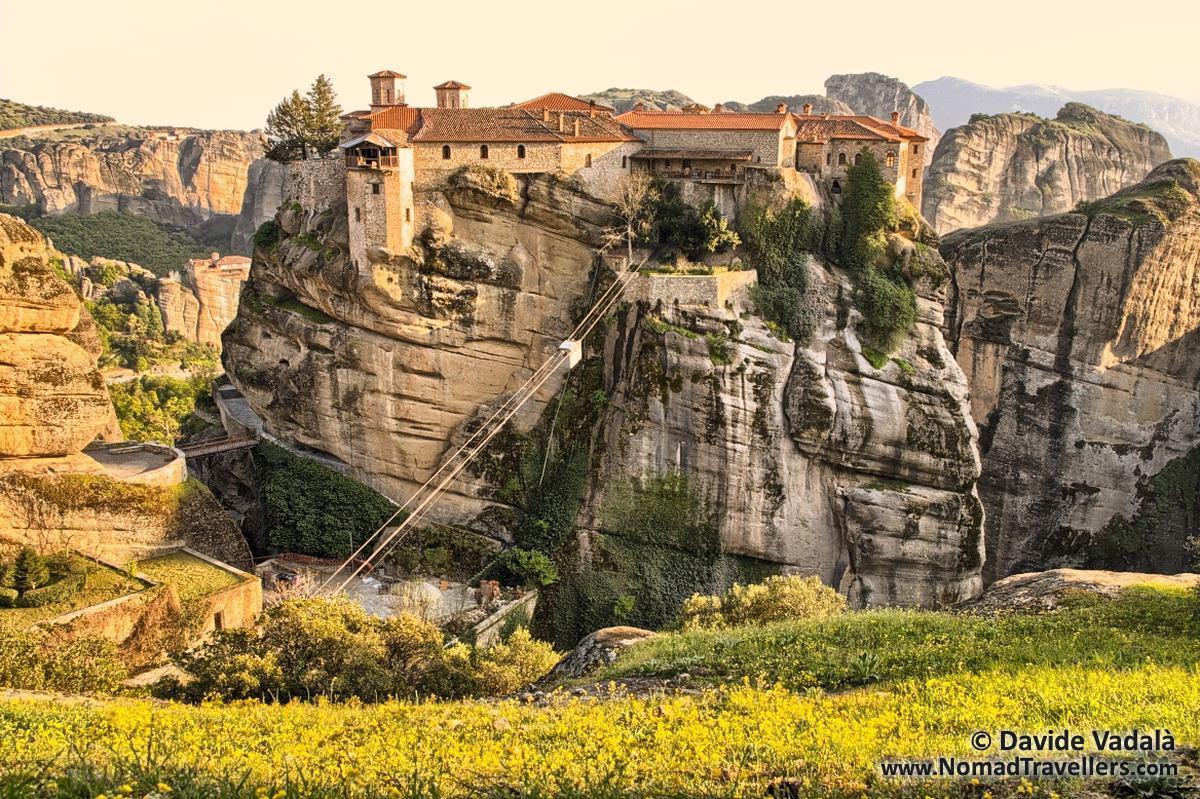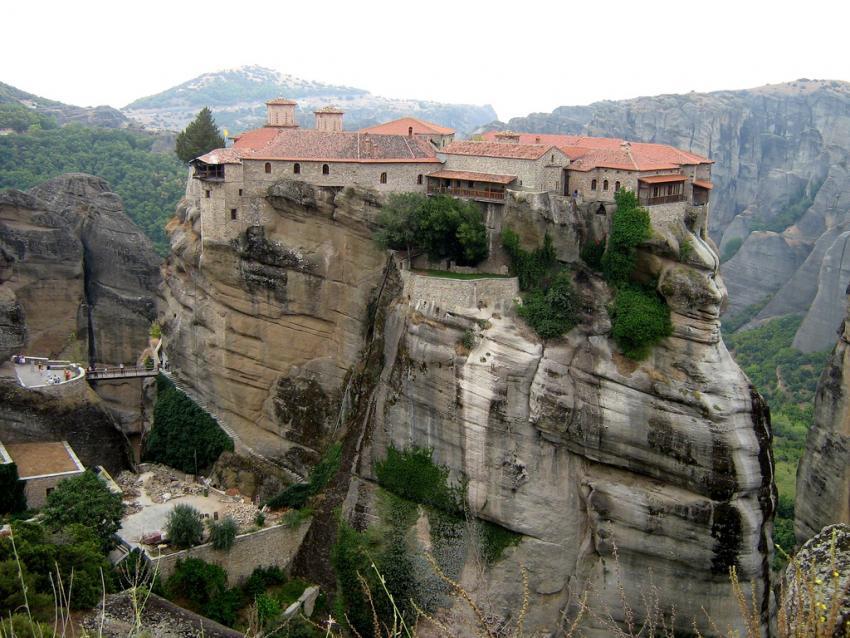The first image is the image on the left, the second image is the image on the right. For the images displayed, is the sentence "Left image includes bright yellow foliage in front of a steep rocky formation topped with an orangish-roofed building." factually correct? Answer yes or no. Yes. The first image is the image on the left, the second image is the image on the right. Assess this claim about the two images: "All images feature buildings constructed on top of large rocks.". Correct or not? Answer yes or no. Yes. 